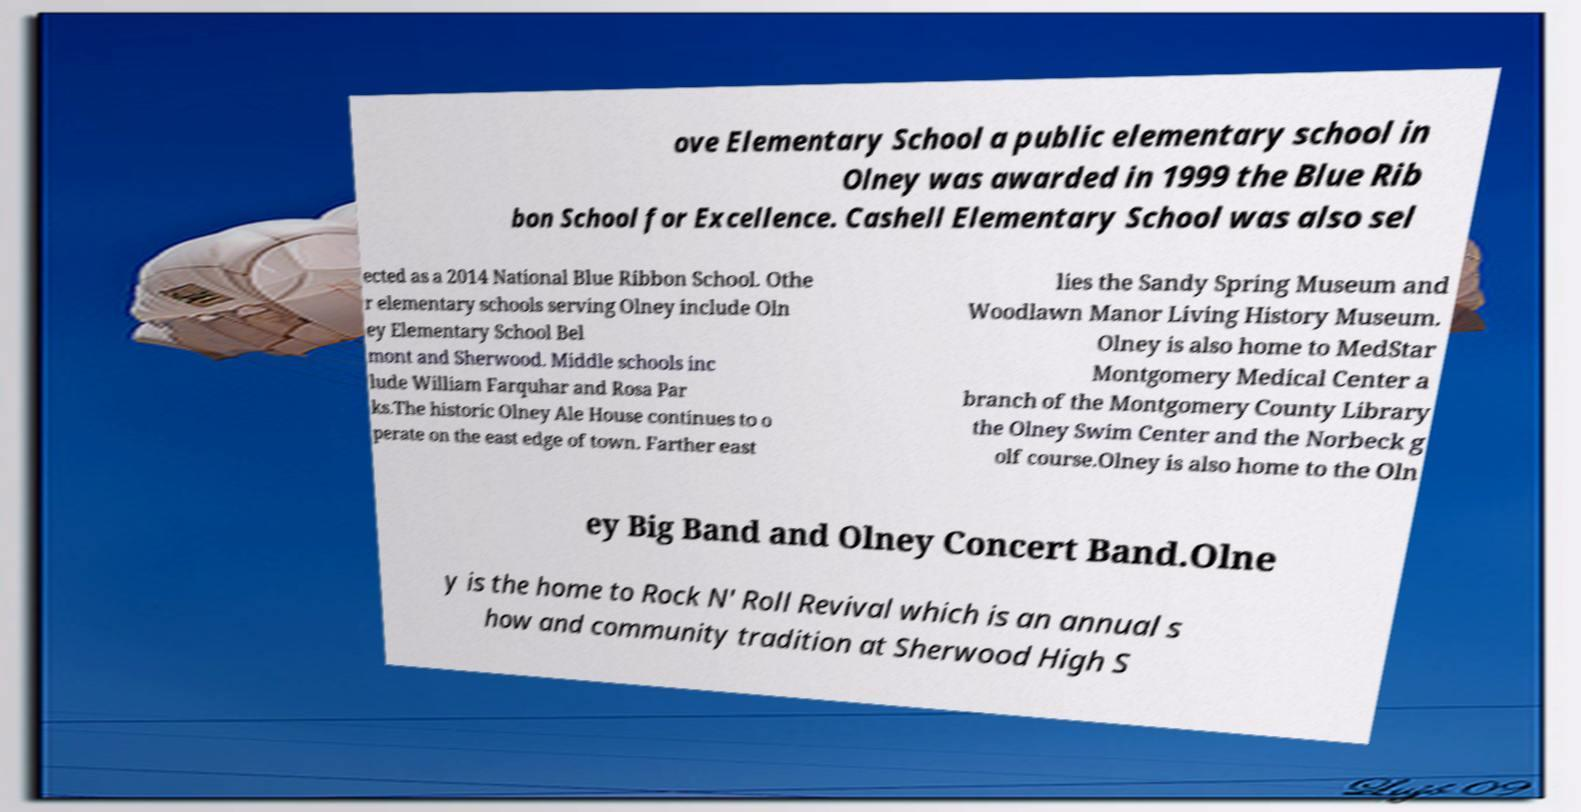Could you extract and type out the text from this image? ove Elementary School a public elementary school in Olney was awarded in 1999 the Blue Rib bon School for Excellence. Cashell Elementary School was also sel ected as a 2014 National Blue Ribbon School. Othe r elementary schools serving Olney include Oln ey Elementary School Bel mont and Sherwood. Middle schools inc lude William Farquhar and Rosa Par ks.The historic Olney Ale House continues to o perate on the east edge of town. Farther east lies the Sandy Spring Museum and Woodlawn Manor Living History Museum. Olney is also home to MedStar Montgomery Medical Center a branch of the Montgomery County Library the Olney Swim Center and the Norbeck g olf course.Olney is also home to the Oln ey Big Band and Olney Concert Band.Olne y is the home to Rock N' Roll Revival which is an annual s how and community tradition at Sherwood High S 